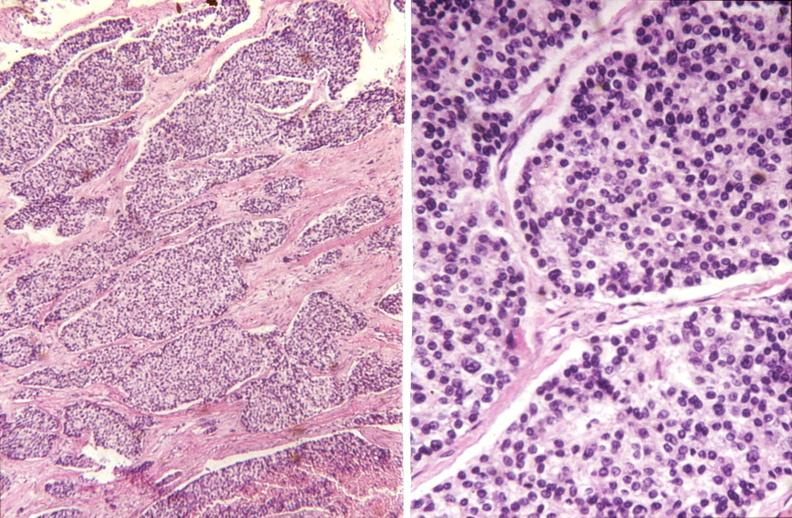s pus in test tube present?
Answer the question using a single word or phrase. No 